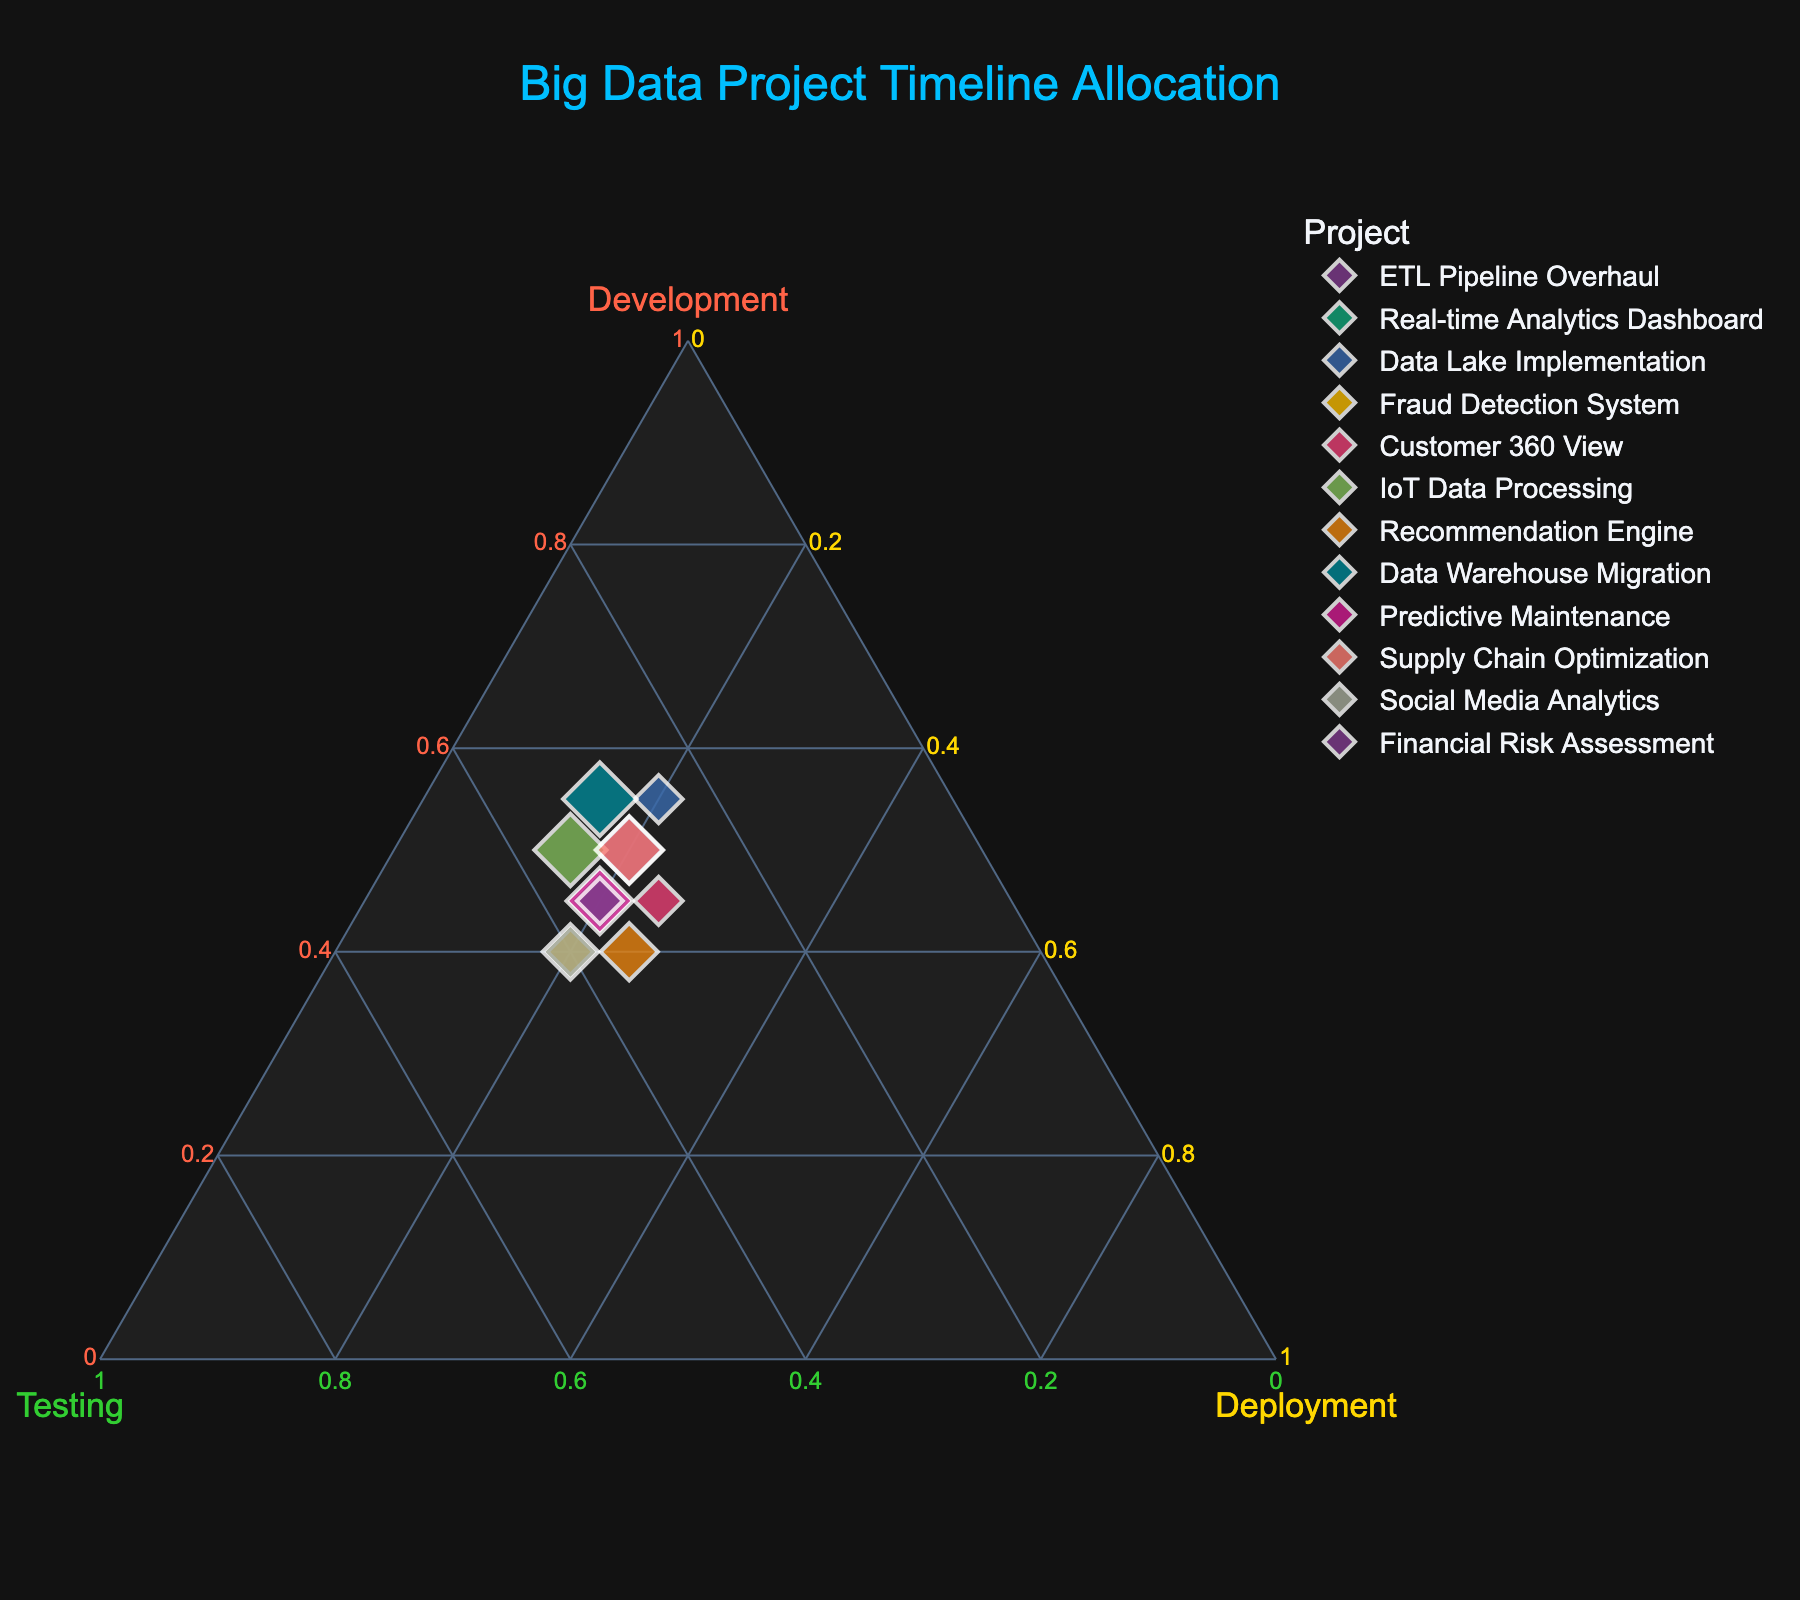What's the title of the figure? Look at the top of the figure where the title is usually displayed. The text indicates the subject of the plot.
Answer: Big Data Project Timeline Allocation How many projects are represented in the figure? Count the number of unique markers or data points in the plot. Each one represents a different project.
Answer: 12 Which project allocates the highest percentage to development? Identify the project whose marker is closest to the vertex labeled 'Development' on the ternary plot.
Answer: Data Lake Implementation For the "Customer 360 View" project, what’s the allocation pattern? Find the position of the "Customer 360 View" marker on the plot. Then, check its coordinates with respect to the Development, Testing, and Deployment axes.
Answer: 45% Development, 30% Testing, 25% Deployment Which two projects have the same allocation for Deployment? Check the plot for projects that share the same percentage along the Deployment axis. These will be on the same horizontal level relative to the Deployment vertex.
Answer: ETL Pipeline Overhaul and Real-time Analytics Dashboard What is the average allocation percentage for Testing among all projects? Retrieve the Testing percentages for all projects and calculate their average. Sum the Testing values and divide by the number of projects.
Answer: 33.33 Which axis is represented by green color? Look at the color-coding of the titles and lines on the ternary plot and match green to the corresponding axis label.
Answer: Testing Is there any project that allocates equally to Testing and Deployment, and what is it? Search for markers where the percentages for Testing and Deployment are equal. These would lie on a line that equally splits the area between Testing and Deployment vertices.
Answer: Fraud Detection System What is the total percentage allocation to Testing for “Predictive Maintenance” and "Financial Risk Assessment" combined? Find the Testing percentages for both projects and sum them together.
Answer: 70% Which project shows an equal split between Development and Testing? Identify the project marker located such that it has equal distances (or percentages) with respect to the Development and Testing vertices.
Answer: Social Media Analytics 